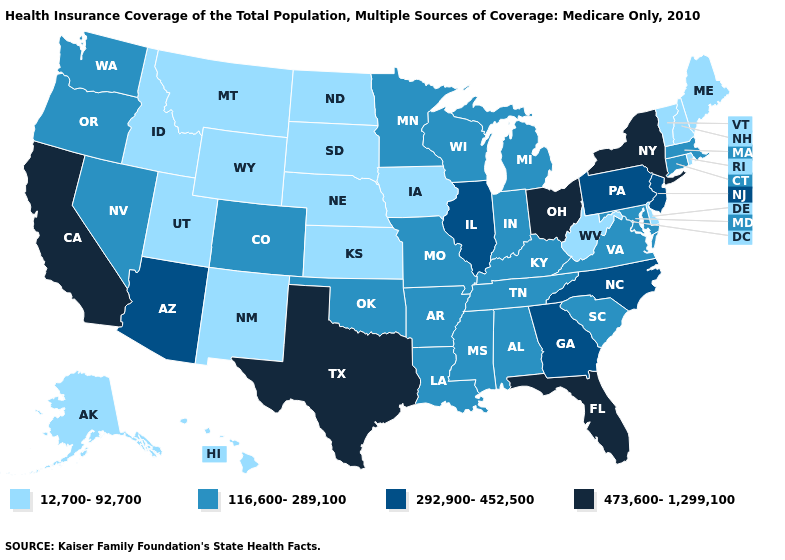Is the legend a continuous bar?
Write a very short answer. No. Which states have the lowest value in the USA?
Quick response, please. Alaska, Delaware, Hawaii, Idaho, Iowa, Kansas, Maine, Montana, Nebraska, New Hampshire, New Mexico, North Dakota, Rhode Island, South Dakota, Utah, Vermont, West Virginia, Wyoming. What is the value of Kansas?
Keep it brief. 12,700-92,700. Does the map have missing data?
Quick response, please. No. Which states have the lowest value in the Northeast?
Quick response, please. Maine, New Hampshire, Rhode Island, Vermont. Does West Virginia have the same value as Delaware?
Quick response, please. Yes. Name the states that have a value in the range 116,600-289,100?
Give a very brief answer. Alabama, Arkansas, Colorado, Connecticut, Indiana, Kentucky, Louisiana, Maryland, Massachusetts, Michigan, Minnesota, Mississippi, Missouri, Nevada, Oklahoma, Oregon, South Carolina, Tennessee, Virginia, Washington, Wisconsin. Does Connecticut have the highest value in the Northeast?
Give a very brief answer. No. Does the first symbol in the legend represent the smallest category?
Keep it brief. Yes. Name the states that have a value in the range 12,700-92,700?
Give a very brief answer. Alaska, Delaware, Hawaii, Idaho, Iowa, Kansas, Maine, Montana, Nebraska, New Hampshire, New Mexico, North Dakota, Rhode Island, South Dakota, Utah, Vermont, West Virginia, Wyoming. What is the lowest value in states that border Oklahoma?
Answer briefly. 12,700-92,700. Among the states that border Arkansas , does Tennessee have the highest value?
Short answer required. No. What is the value of Arkansas?
Answer briefly. 116,600-289,100. Name the states that have a value in the range 292,900-452,500?
Write a very short answer. Arizona, Georgia, Illinois, New Jersey, North Carolina, Pennsylvania. Does Idaho have a lower value than California?
Quick response, please. Yes. 